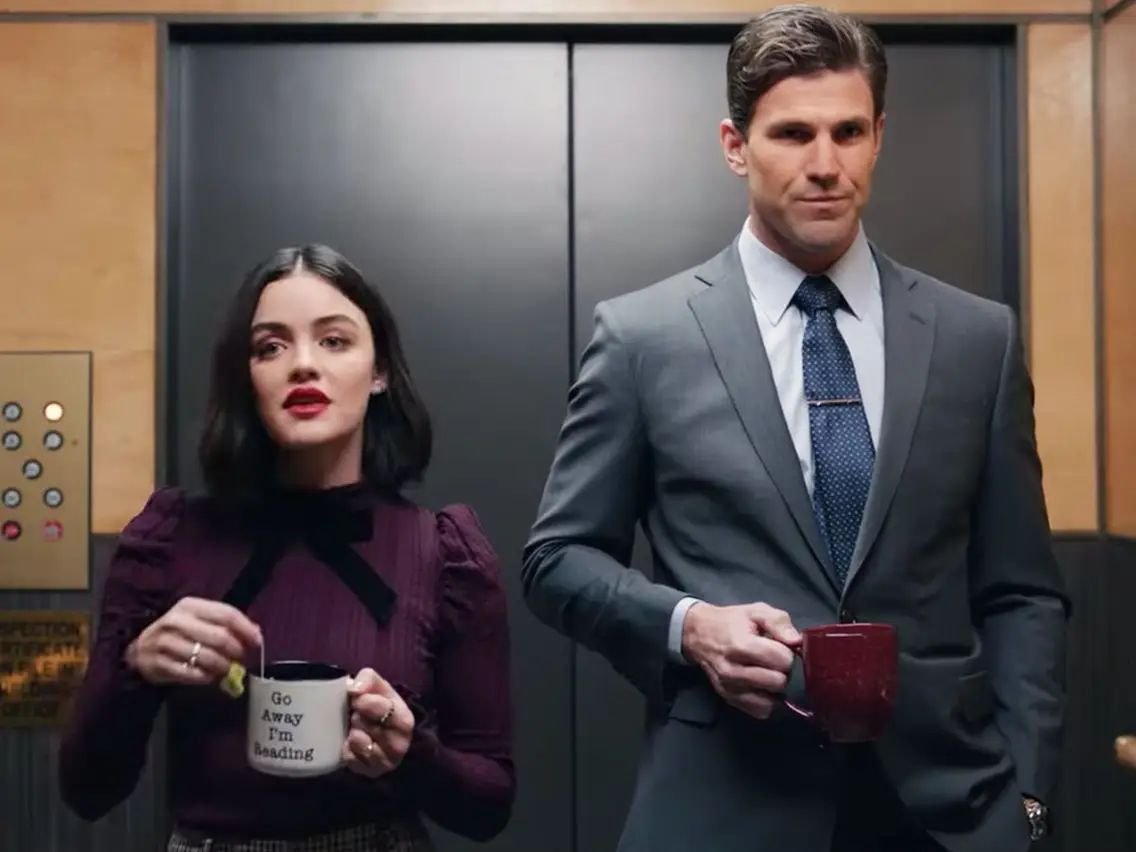What could be the potential context or backstory of this scene? This scene might depict an unexpected and private conversation in an elevator. Lucy Hale, with her engaging mug and surprised look, might be reacting to some unforeseen news or an awkward situation. The gentleman, dressed in business attire, could be a colleague or boss, maintaining a composed and serious posture. Their contrasting expressions could hint at an event that just occurred, such as a sudden revelation or an unexpected encounter. Given the setting and their expressions, what dialogue would you imagine taking place between them? Lucy Hale: 'I can’t believe you actually went through with it. Are you serious?' 
Man: 'Yes, it was necessary for the project’s success.' 
Lucy Hale: 'But without consulting the team first?'
Man: 'We needed a quick decision, and I took the responsibility. We can discuss the details in the meeting.' 